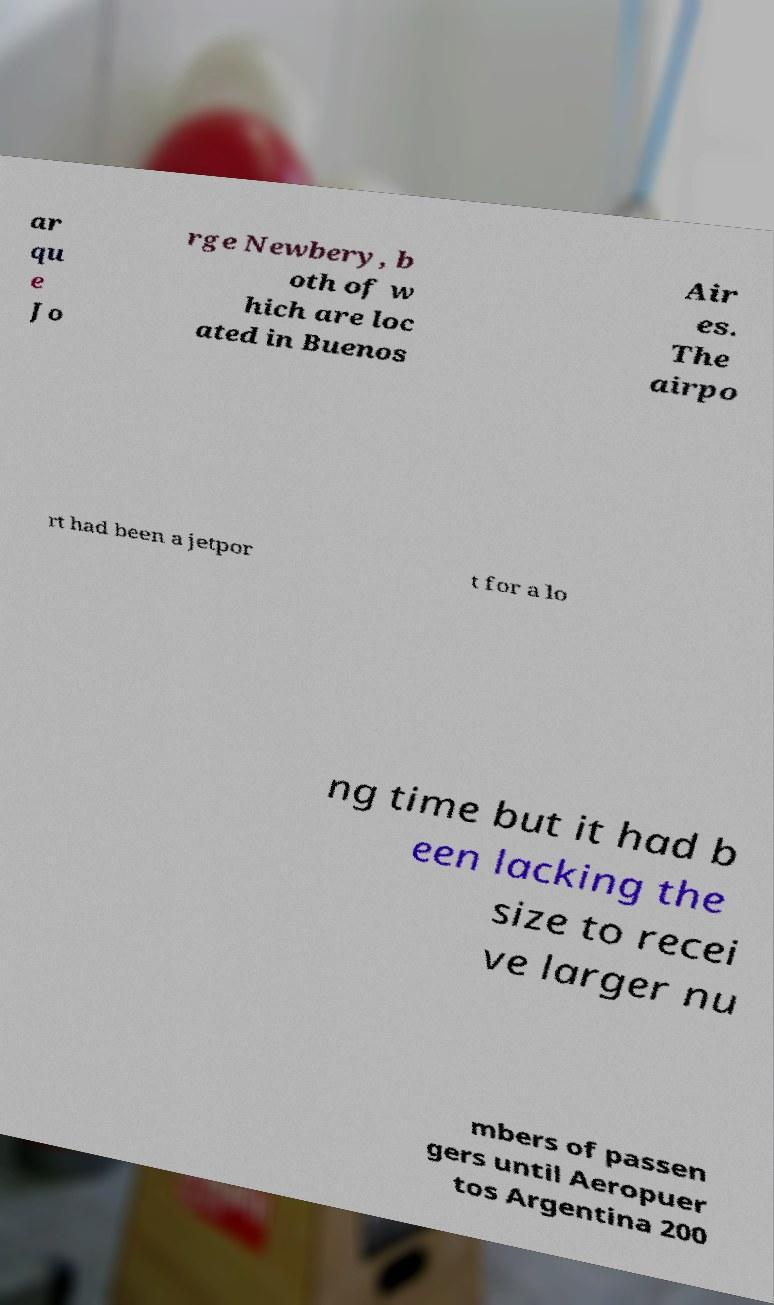Could you assist in decoding the text presented in this image and type it out clearly? ar qu e Jo rge Newbery, b oth of w hich are loc ated in Buenos Air es. The airpo rt had been a jetpor t for a lo ng time but it had b een lacking the size to recei ve larger nu mbers of passen gers until Aeropuer tos Argentina 200 